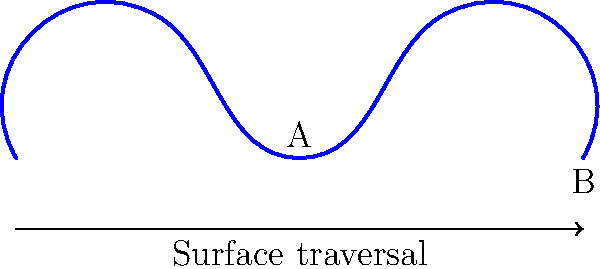A Möbius strip is created by taking a rectangular strip and giving it a half-twist before joining the ends. If you start at point A on the surface and travel along the length of the strip, at which point will you end up after one complete traversal? Consider how this relates to the unexpected turns in a public figure's career. To understand this problem, let's break it down step-by-step:

1) A Möbius strip has only one side and one edge, despite appearing to have two of each.

2) When you travel along the surface of a Möbius strip:
   - You traverse what seems to be both sides of the original strip.
   - You return to your starting point after traveling twice the length of the original strip.

3) In this case:
   - Starting at point A, you begin on what appears to be the "top" of the strip.
   - As you travel, you gradually move to what seems to be the "bottom" of the strip.
   - After one complete traversal (one length of the original strip), you end up on the "opposite" side.

4) Therefore, after one complete traversal:
   - You will be at point A again (same position).
   - However, you'll be on what appears to be the opposite side of where you started.

5) This is analogous to how a public figure's career can take unexpected turns:
   - They might end up in a similar position (point A) but with a completely different public perception (opposite side).
Answer: Point A, but on the opposite side of the strip 